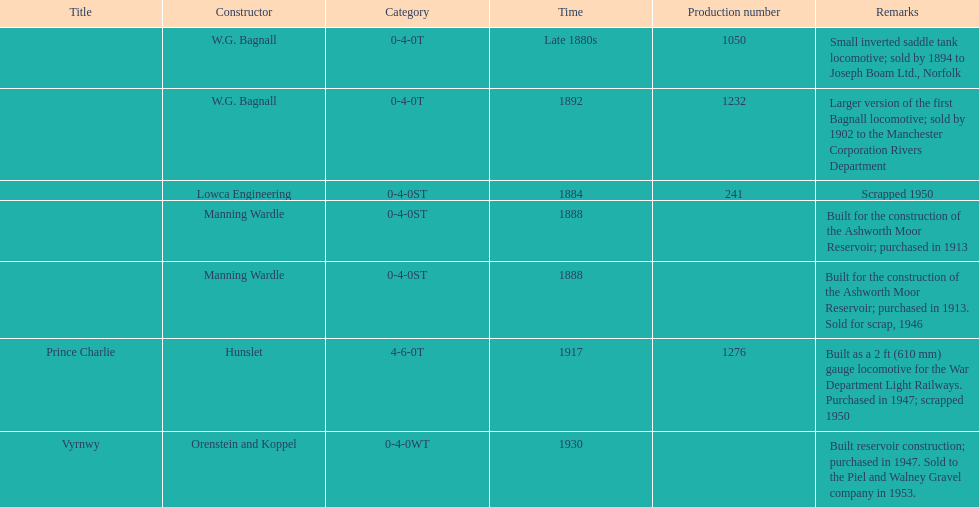What was the last locomotive? Vyrnwy. 